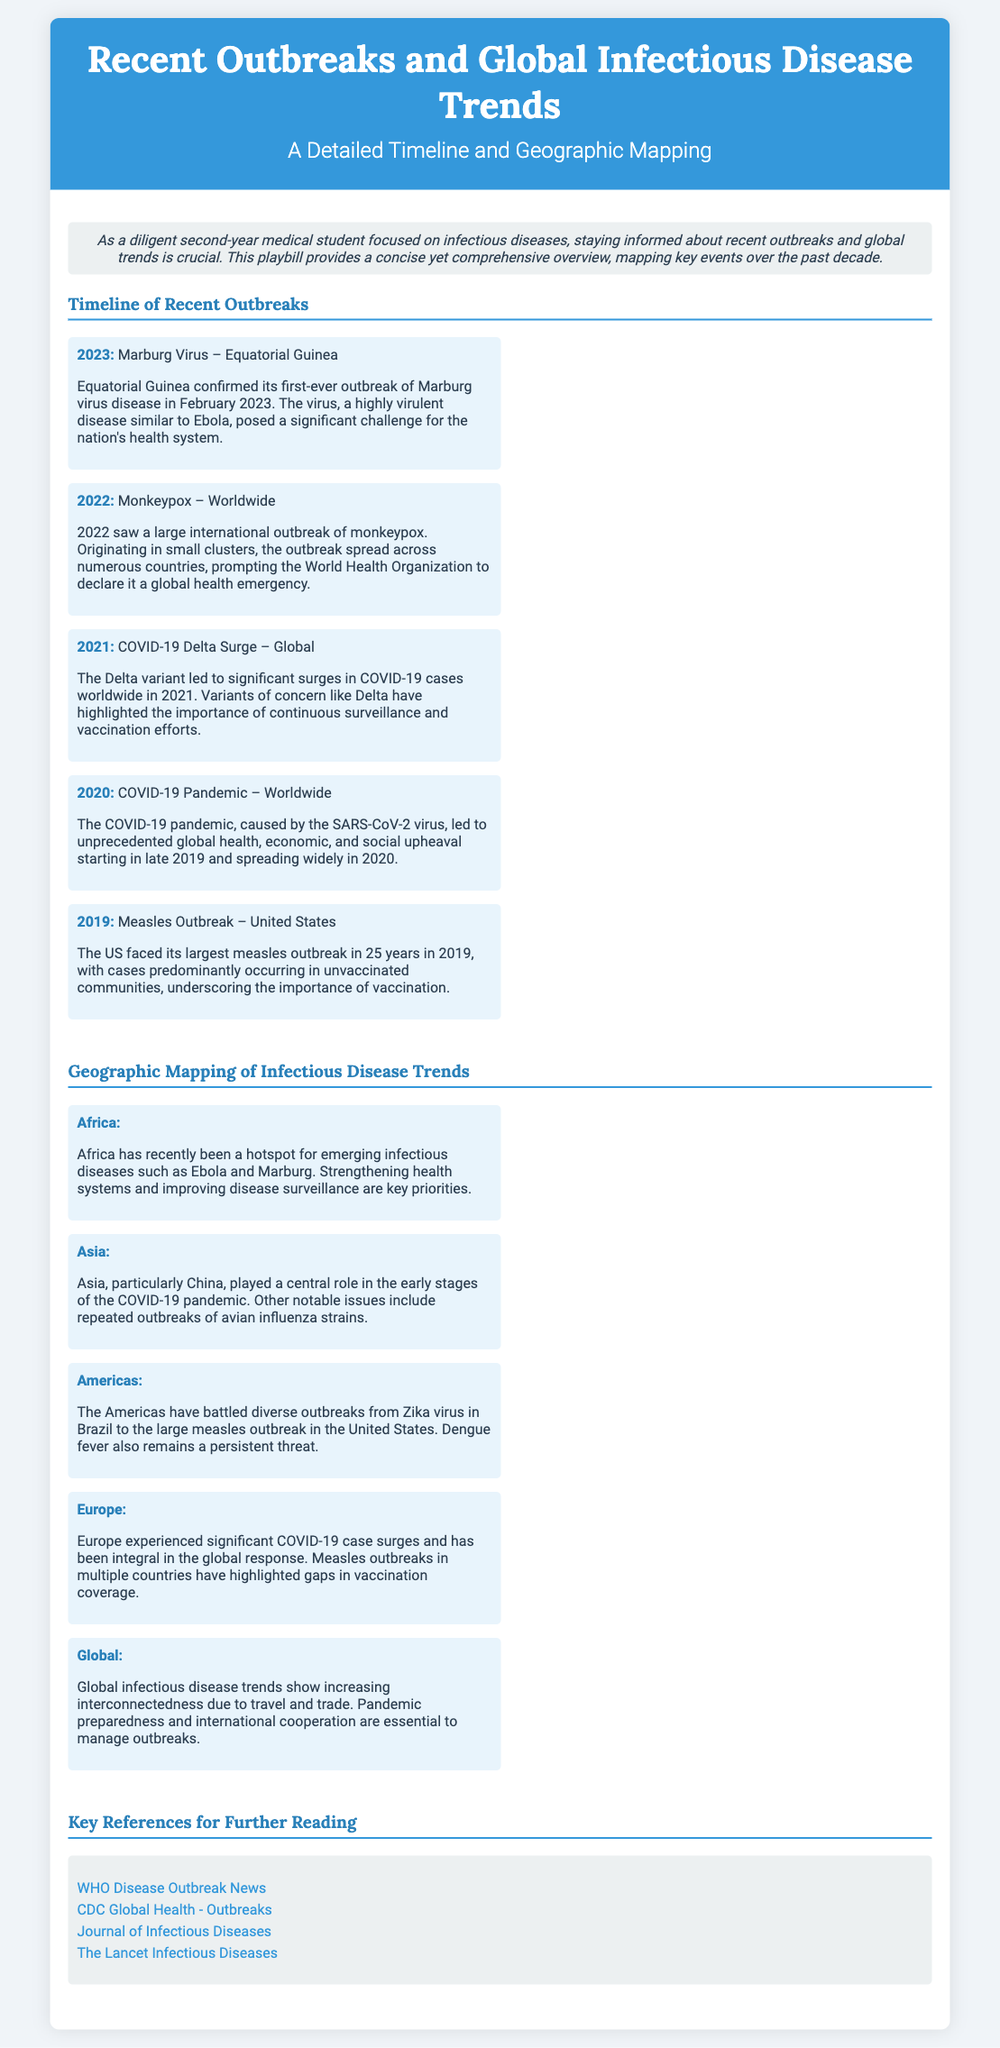What outbreak occurred in Equatorial Guinea in 2023? The document states that the Marburg virus outbreak was confirmed in Equatorial Guinea in 2023.
Answer: Marburg Virus What major outbreak was declared a global health emergency in 2022? According to the document, the Monkeypox outbreak was declared a global health emergency by the WHO in 2022.
Answer: Monkeypox Which variant caused significant COVID-19 surges in 2021? The document mentions that the Delta variant led to surges in COVID-19 cases worldwide in 2021.
Answer: Delta What is a key priority for Africa regarding infectious diseases? The document highlights that strengthening health systems and improving disease surveillance are key priorities in Africa.
Answer: Strengthening health systems Which region faced a large measles outbreak in 2019? The document indicates that the United States faced its largest measles outbreak in 2019.
Answer: United States What global issue has the Americas been battling in terms of outbreaks? The document lists diverse outbreaks including the Zika virus and measles in the Americas, indicating it has faced varied infectious disease challenges.
Answer: Zika virus and measles What is a common theme across recent global infectious disease trends? The timeline suggests that increasing interconnectedness due to travel and trade is a common theme across global infectious disease trends.
Answer: Increasing interconnectedness What is a recommended resource for further reading on disease outbreaks? The document provides several links, including the WHO Disease Outbreak News, as a recommended resource for further reading.
Answer: WHO Disease Outbreak News 